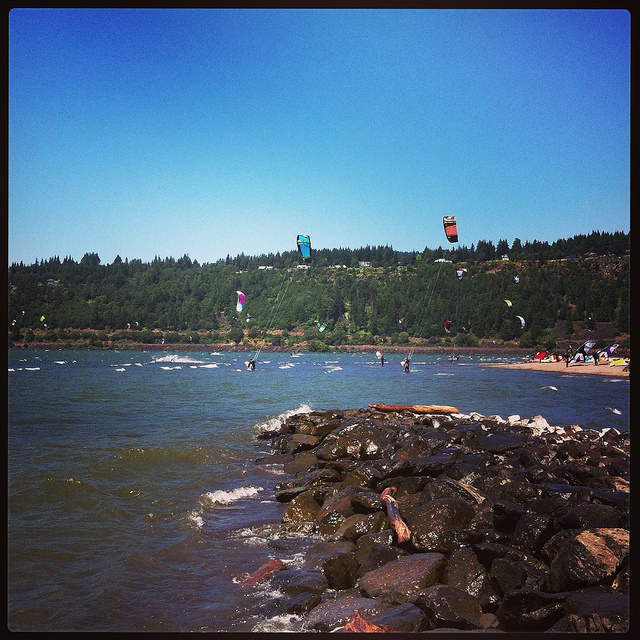<image>What is the name of the pattern appearing on top of the picture? I don't know what the name of the pattern appearing on top of the picture is. It could be a gradient, frame, sky, or zig zag. What is the yellow object in the water? I don't know what the yellow object in the water is. It could be a boat, a bird, sand, a person, a surfboard, a sailboard or a kite. What is the yellow object in the water? I don't know what the yellow object in the water is. It can be a boat, surfboard, sailboard or kite. What is the name of the pattern appearing on top of the picture? I don't know the name of the pattern appearing on top of the picture. It can be seen 'gradient', 'frame', 'sky', 'none', 'natural', 'solid', 'zig zag', or 'border'. 